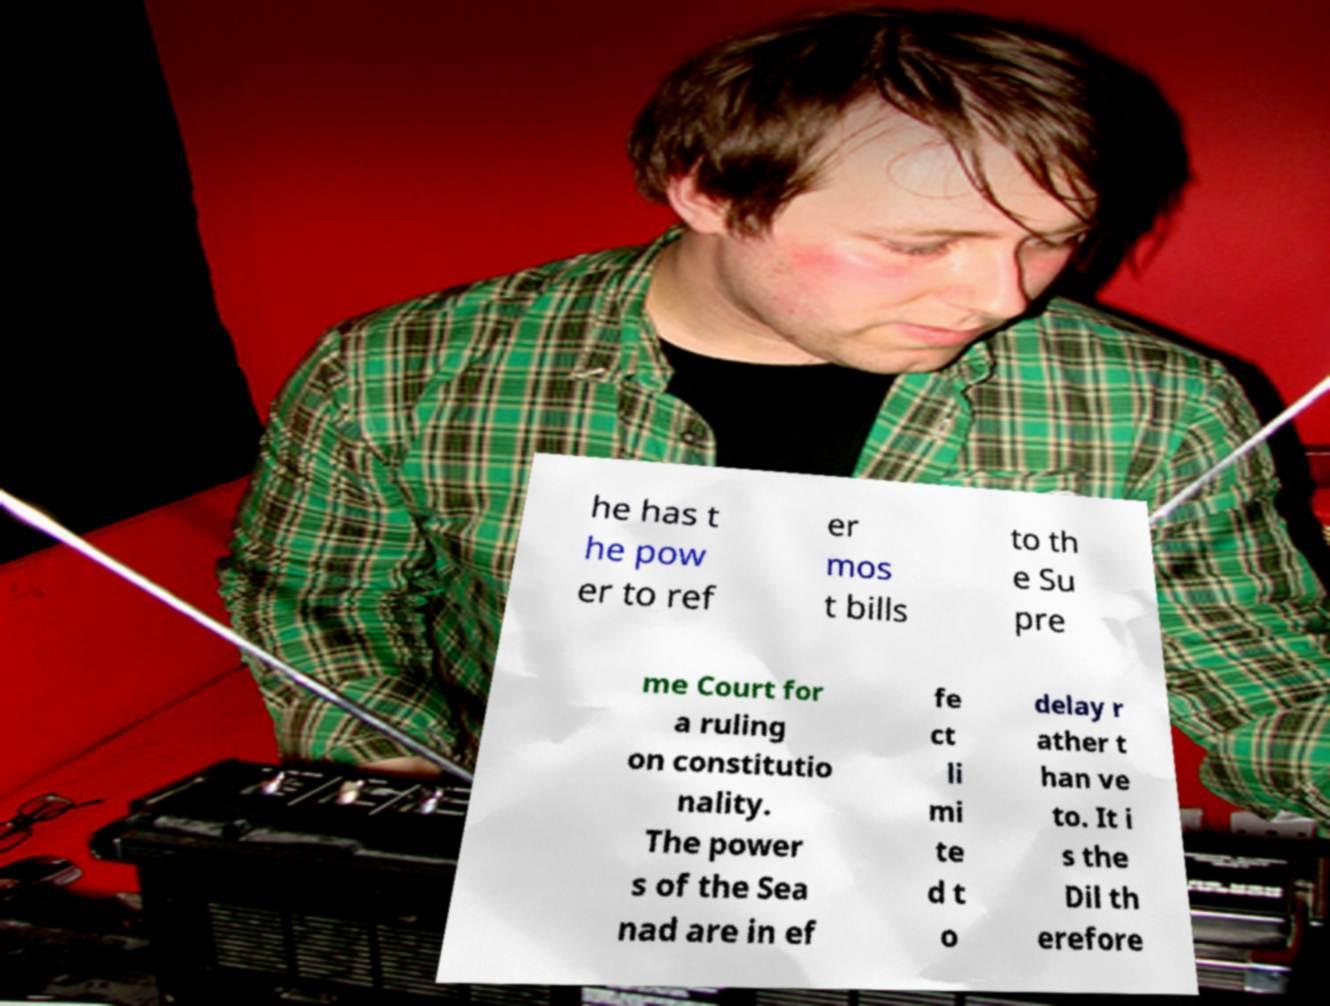For documentation purposes, I need the text within this image transcribed. Could you provide that? he has t he pow er to ref er mos t bills to th e Su pre me Court for a ruling on constitutio nality. The power s of the Sea nad are in ef fe ct li mi te d t o delay r ather t han ve to. It i s the Dil th erefore 